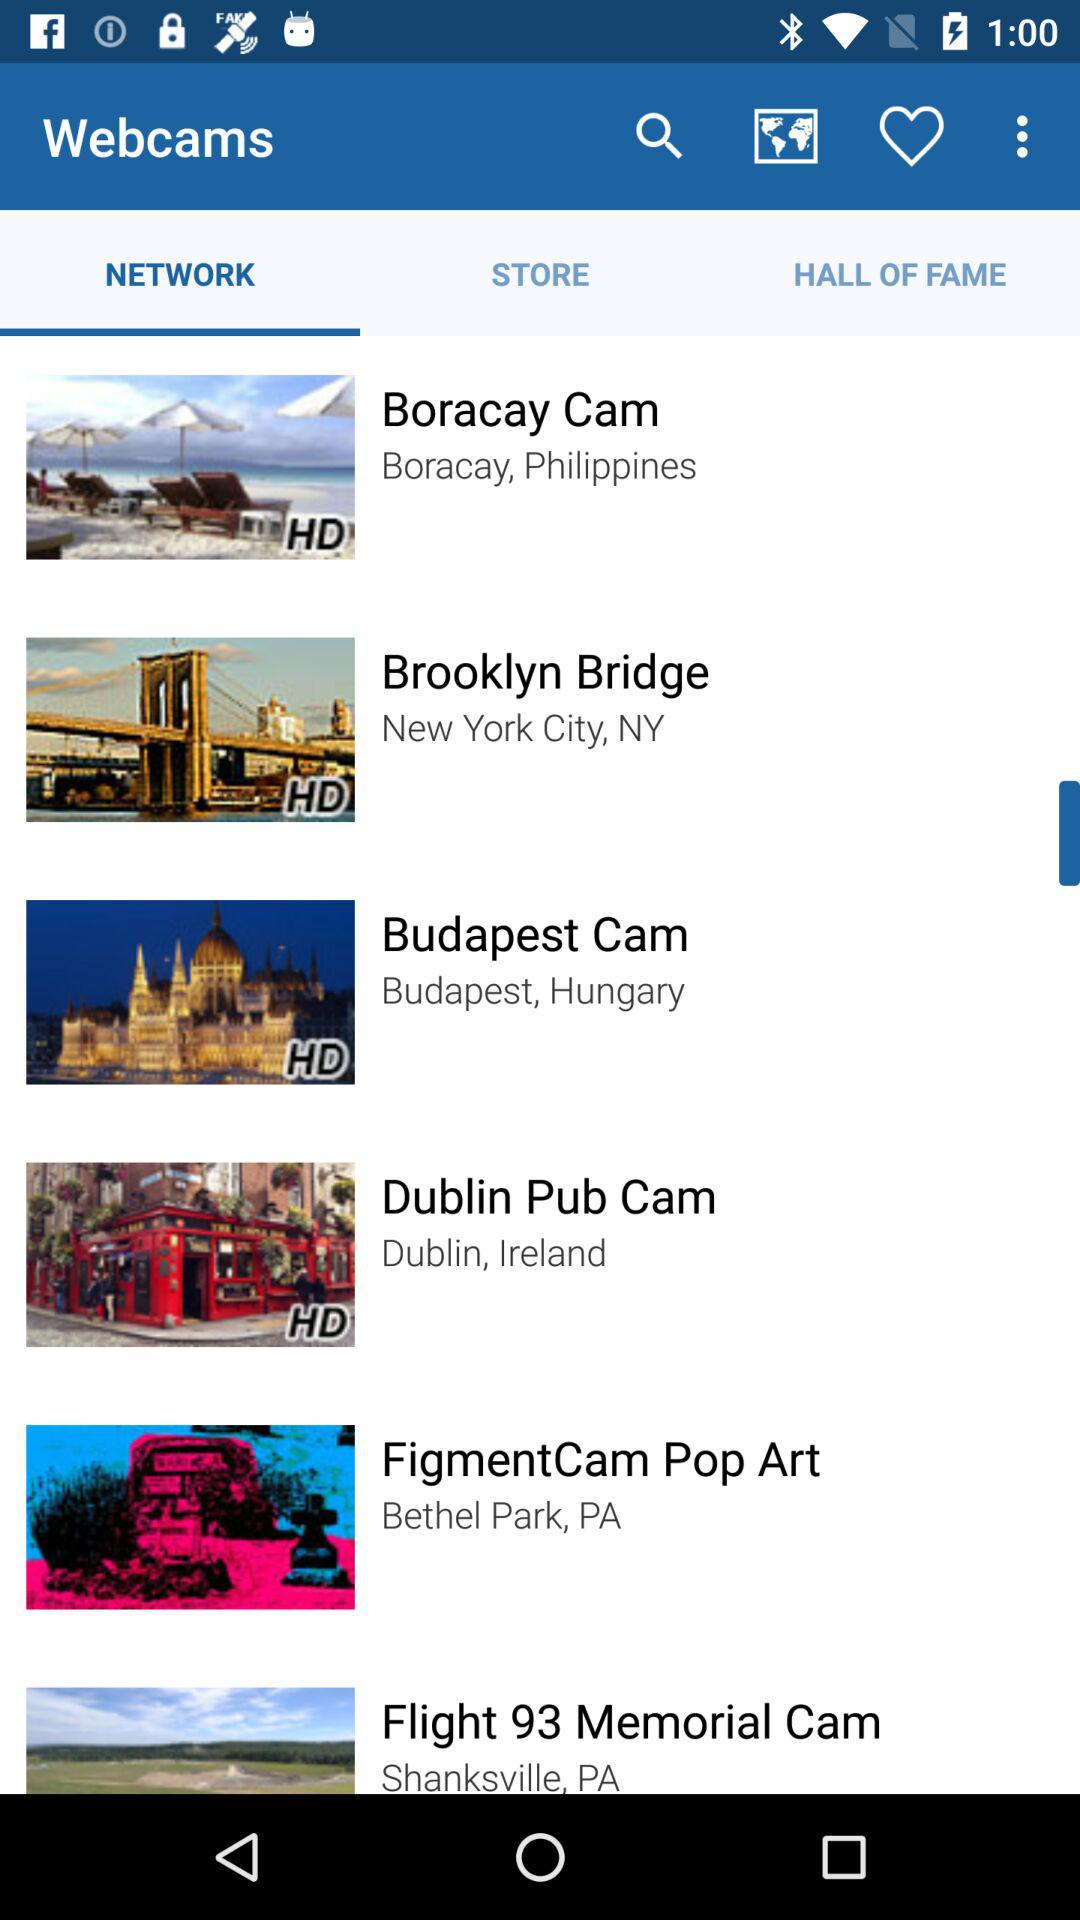How many webcams are featured in the app?
Answer the question using a single word or phrase. 6 